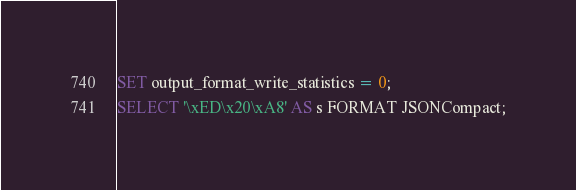Convert code to text. <code><loc_0><loc_0><loc_500><loc_500><_SQL_>SET output_format_write_statistics = 0;
SELECT '\xED\x20\xA8' AS s FORMAT JSONCompact;
</code> 